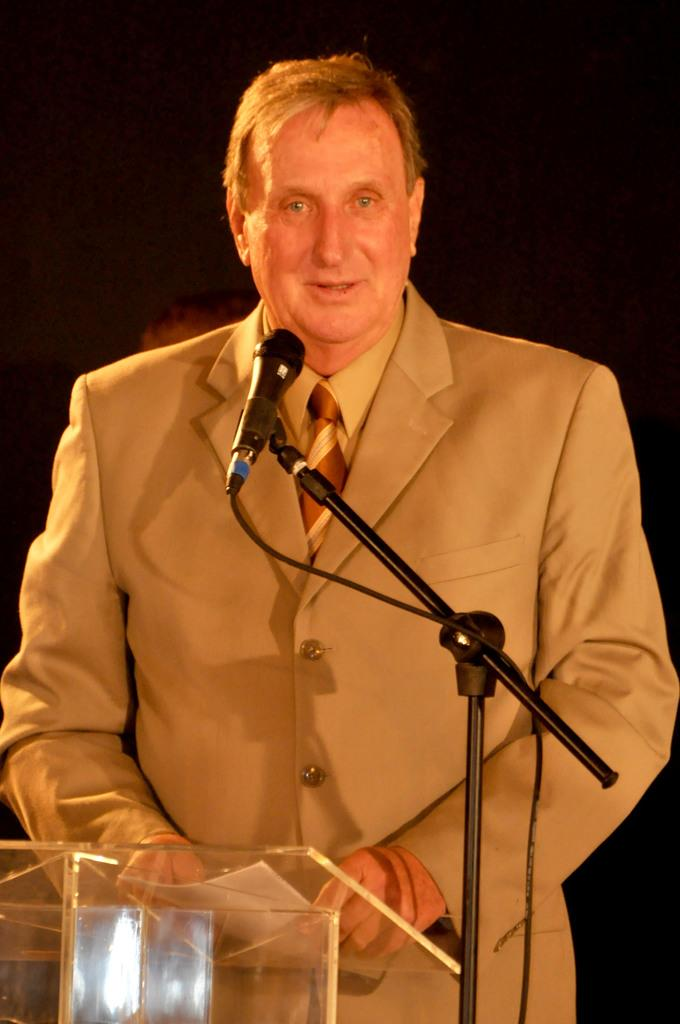What is the man in the image doing? The man is standing at a podium and speaking with the help of a microphone. What is the man holding in his hands? The man is holding a paper in his hands. What is the lighting condition in the image? The background of the image is dark. Can you see any clouds in the image? There are no clouds visible in the image, as the focus is on the man and his surroundings do not include the sky. 